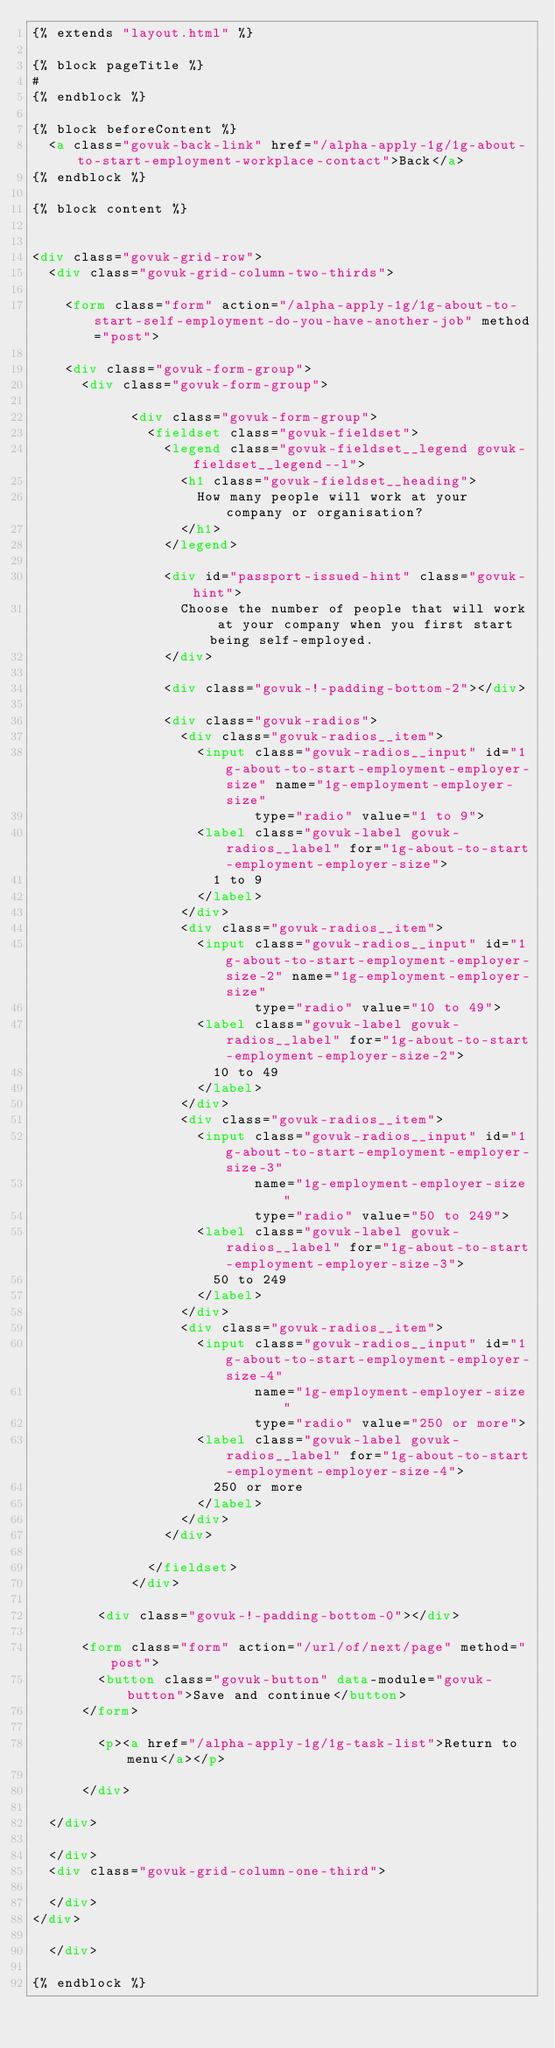<code> <loc_0><loc_0><loc_500><loc_500><_HTML_>{% extends "layout.html" %}

{% block pageTitle %}
#
{% endblock %}

{% block beforeContent %}
  <a class="govuk-back-link" href="/alpha-apply-1g/1g-about-to-start-employment-workplace-contact">Back</a>
{% endblock %}

{% block content %}


<div class="govuk-grid-row">
  <div class="govuk-grid-column-two-thirds">

    <form class="form" action="/alpha-apply-1g/1g-about-to-start-self-employment-do-you-have-another-job" method="post">

    <div class="govuk-form-group">
      <div class="govuk-form-group">

            <div class="govuk-form-group">
              <fieldset class="govuk-fieldset">
                <legend class="govuk-fieldset__legend govuk-fieldset__legend--l">
                  <h1 class="govuk-fieldset__heading">
                    How many people will work at your company or organisation?
                  </h1>
                </legend>

                <div id="passport-issued-hint" class="govuk-hint">
                  Choose the number of people that will work at your company when you first start being self-employed.
                </div>

                <div class="govuk-!-padding-bottom-2"></div>

                <div class="govuk-radios">
                  <div class="govuk-radios__item">
                    <input class="govuk-radios__input" id="1g-about-to-start-employment-employer-size" name="1g-employment-employer-size"
                           type="radio" value="1 to 9">
                    <label class="govuk-label govuk-radios__label" for="1g-about-to-start-employment-employer-size">
                      1 to 9
                    </label>
                  </div>
                  <div class="govuk-radios__item">
                    <input class="govuk-radios__input" id="1g-about-to-start-employment-employer-size-2" name="1g-employment-employer-size"
                           type="radio" value="10 to 49">
                    <label class="govuk-label govuk-radios__label" for="1g-about-to-start-employment-employer-size-2">
                      10 to 49
                    </label>
                  </div>
                  <div class="govuk-radios__item">
                    <input class="govuk-radios__input" id="1g-about-to-start-employment-employer-size-3"
                           name="1g-employment-employer-size"
                           type="radio" value="50 to 249">
                    <label class="govuk-label govuk-radios__label" for="1g-about-to-start-employment-employer-size-3">
                      50 to 249
                    </label>
                  </div>
                  <div class="govuk-radios__item">
                    <input class="govuk-radios__input" id="1g-about-to-start-employment-employer-size-4"
                           name="1g-employment-employer-size"
                           type="radio" value="250 or more">
                    <label class="govuk-label govuk-radios__label" for="1g-about-to-start-employment-employer-size-4">
                      250 or more
                    </label>
                  </div>
                </div>

              </fieldset>
            </div>

        <div class="govuk-!-padding-bottom-0"></div>

      <form class="form" action="/url/of/next/page" method="post">
        <button class="govuk-button" data-module="govuk-button">Save and continue</button>
      </form>

        <p><a href="/alpha-apply-1g/1g-task-list">Return to menu</a></p>

      </div>

  </div>

  </div>
  <div class="govuk-grid-column-one-third">

  </div>
</div>

  </div>

{% endblock %}
</code> 